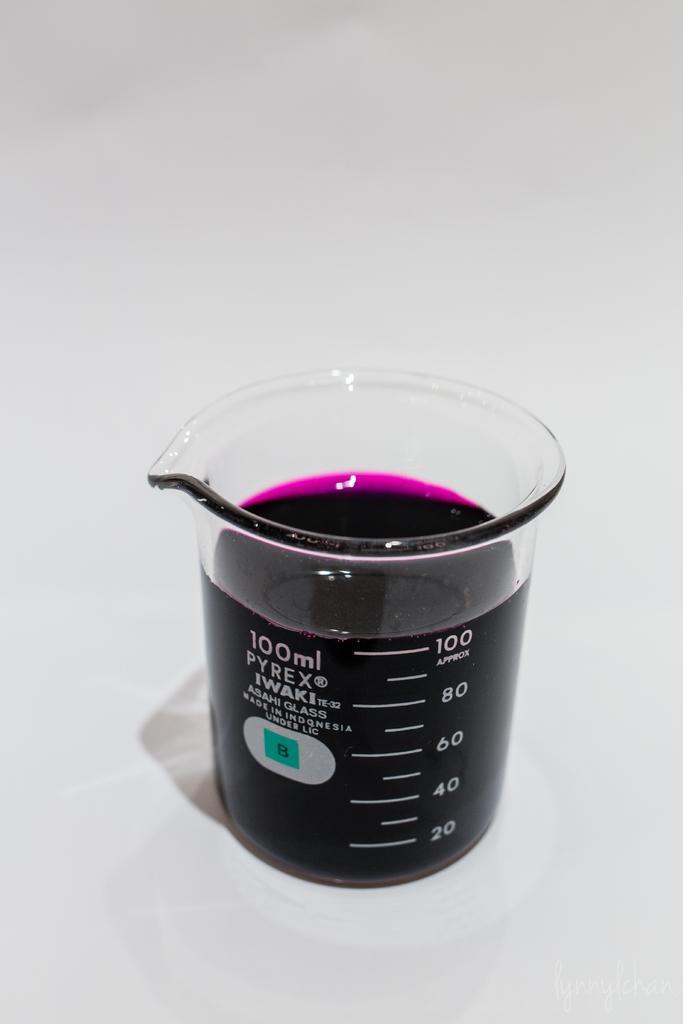Describe this image in one or two sentences. In this image, we can see a measuring jar with liquid is placed on the white surface. 